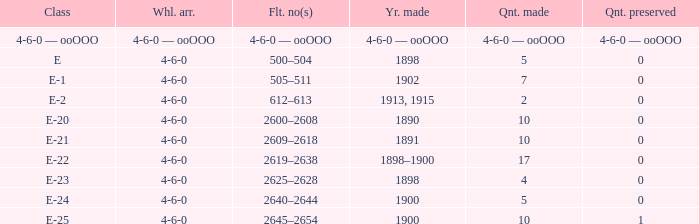What is the quantity preserved of the e-1 class? 0.0. 